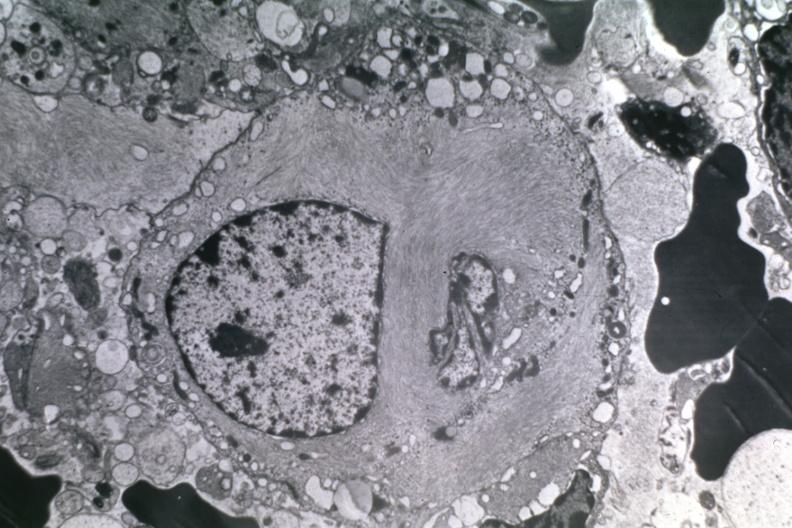what is present?
Answer the question using a single word or phrase. Brain 